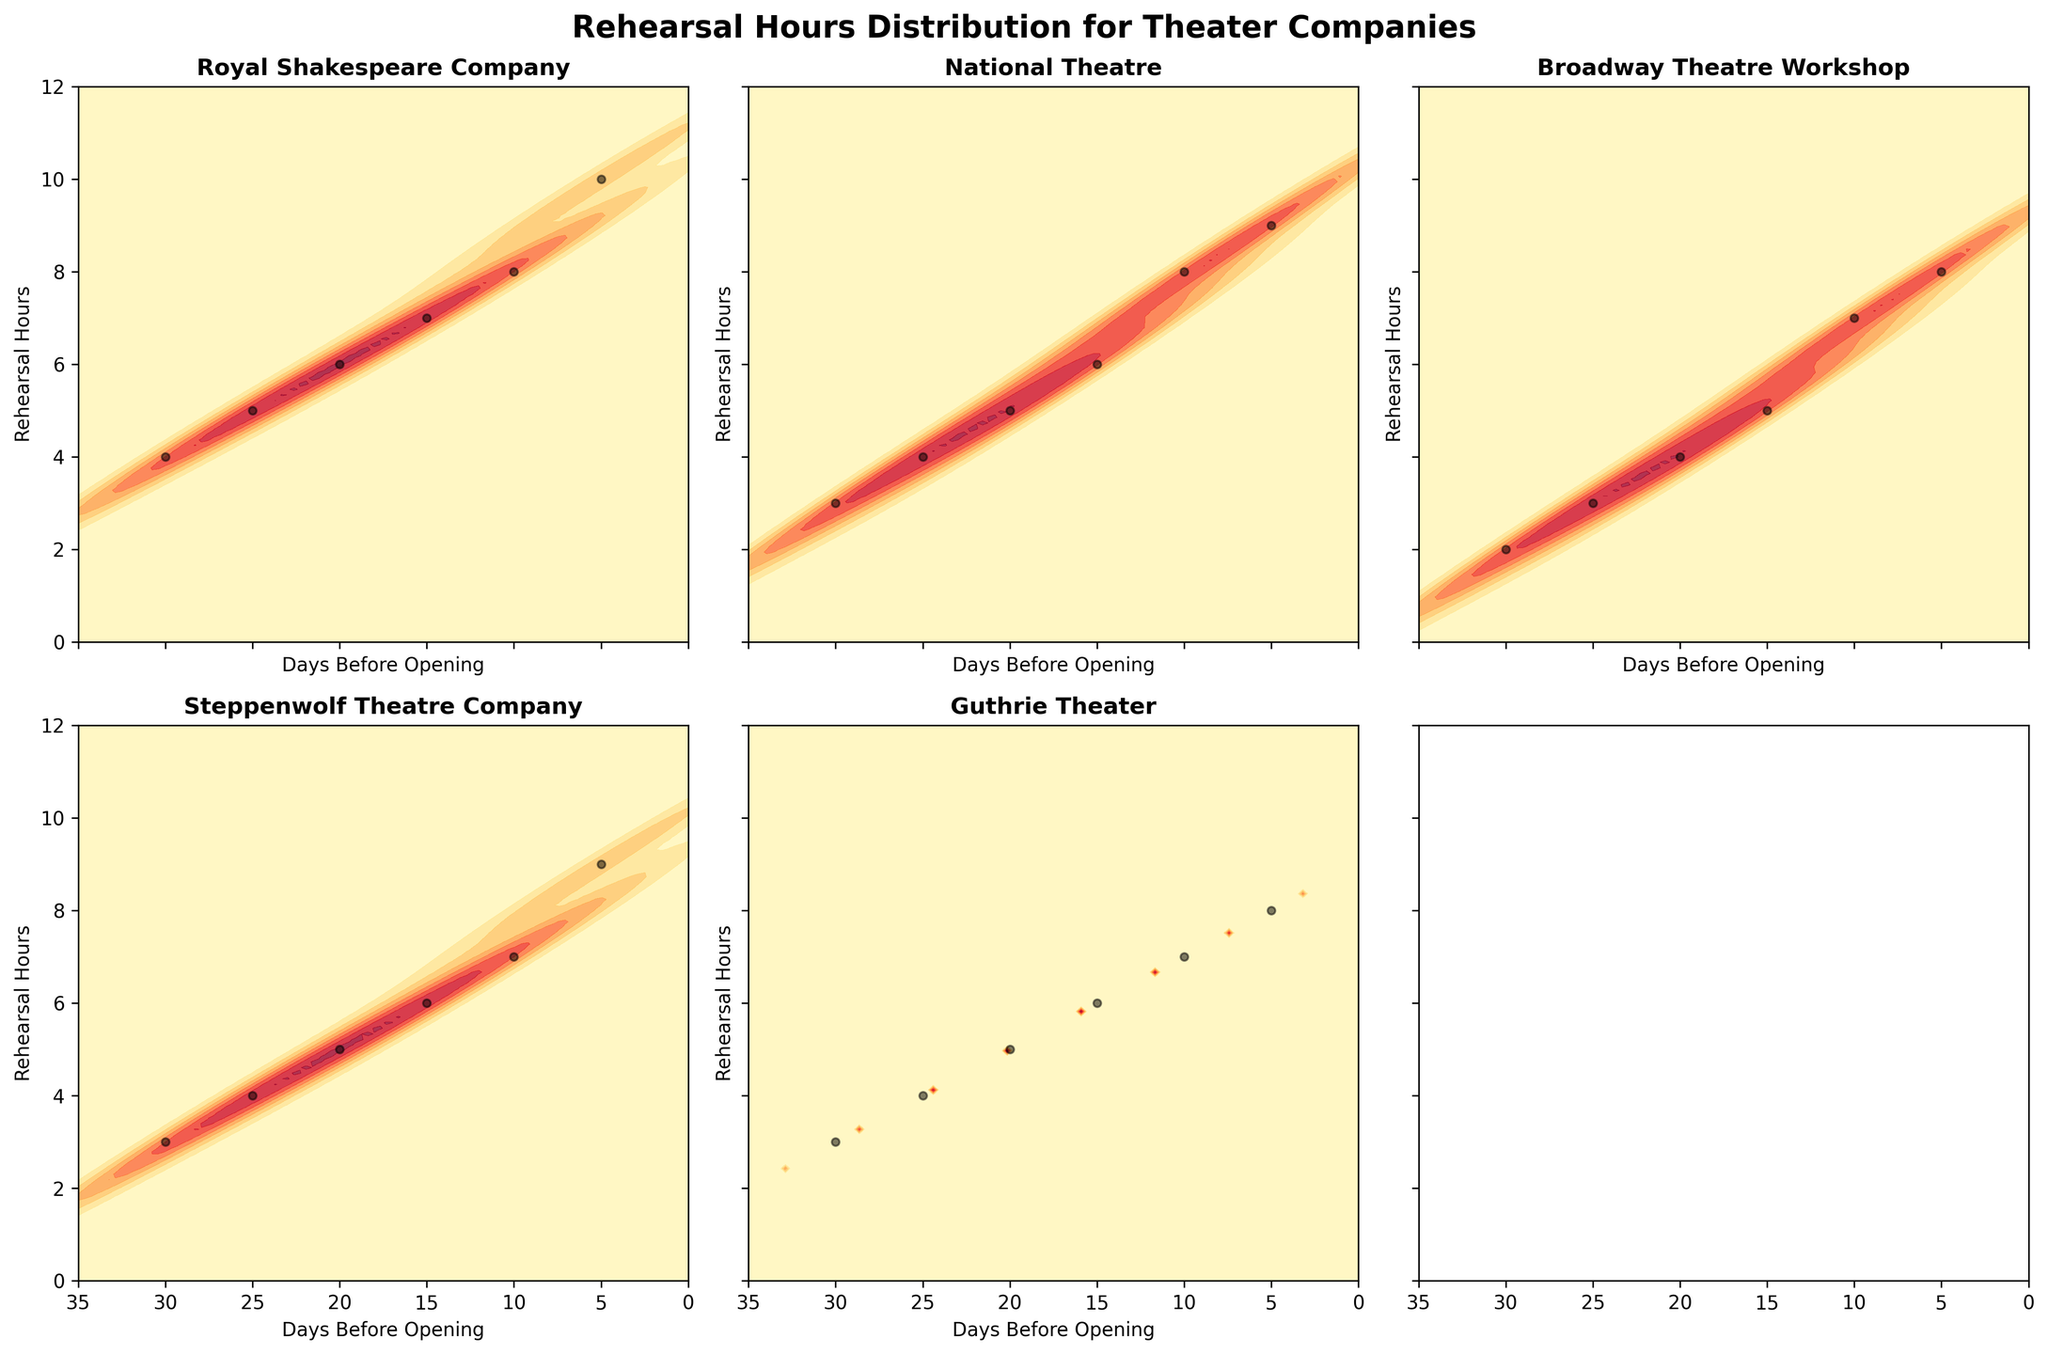What is the title of the overall figure? The figure's title is located at the top and provides a brief description of the content being displayed. It reads: "Rehearsal Hours Distribution for Theater Companies".
Answer: Rehearsal Hours Distribution for Theater Companies What are the labels on the x-axis and y-axis? Each subplot includes an x-axis and y-axis label. The x-axis is labeled "Days Before Opening" and the y-axis is labeled "Rehearsal Hours".
Answer: Days Before Opening, Rehearsal Hours Which theater company spends the most rehearsal hours 5 days before opening night? By looking at the data points on the subplots for each theater company at the 5-days-before marker, the Royal Shakespeare Company has the highest data point at 10 rehearsal hours.
Answer: Royal Shakespeare Company How does the rehearsal hour distribution of the Broadway Theatre Workshop differ from the Royal Shakespeare Company? By comparing the contour plots of both companies, the Broadway Theatre Workshop rehearses less than the Royal Shakespeare Company throughout the 30-day period, maxing at 8 hours compared to 10.
Answer: Broadway Theatre Workshop rehearses less What pattern is noticeable in the rehearsal hours 10 days before opening across all theater companies? Observing the 10-day marker, most theater companies show an increase in rehearsal hours as the opening night approaches, with hours ranging from 7-8. This indicates a general trend of ramping up rehearsals closer to the opening night.
Answer: Increase in rehearsal hours Which theater company shows the least variability in rehearsal hours over the 30-day period? By examining the density plots, the Broadway Theatre Workshop shows the least variability in rehearsal hours, as the contour plot is more consistent and less spread out compared to others.
Answer: Broadway Theatre Workshop Do all theater companies increase their rehearsal hours as the opening night approaches? The contour plots for all companies indicate an upward trend in rehearsal hours as the days decrease, thus showing that all theater companies increase their rehearsal hours closer to opening night.
Answer: Yes, they do What is the range of rehearsal hours for the National Theatre from 30 days to 5 days before opening night? From the subplot, observe the data points for the National Theatre between 30 and 5 days, ranging from 3 to 9 rehearsal hours.
Answer: 3 to 9 hours How do the rehearsal hours for Guthrie Theater 15 days before opening compare to those of Steppenwolf Theatre Company on the same day? Referring to the specific day on both plots, Guthrie Theater has approximately 6-hours, which is the same as Steppenwolf Theatre Company, indicating equal rehearsal hours for that day.
Answer: Equal hours, 6 hours Which company shows the steepest increase in rehearsal hours as they approach the opening night? The steepness is derived from the density of the contour lines closer to the plot's right side. The Royal Shakespeare Company and National Theatre show steep increases, but the Royal Shakespeare Company shows the steepest increase topping at 10 hours.
Answer: Royal Shakespeare Company 